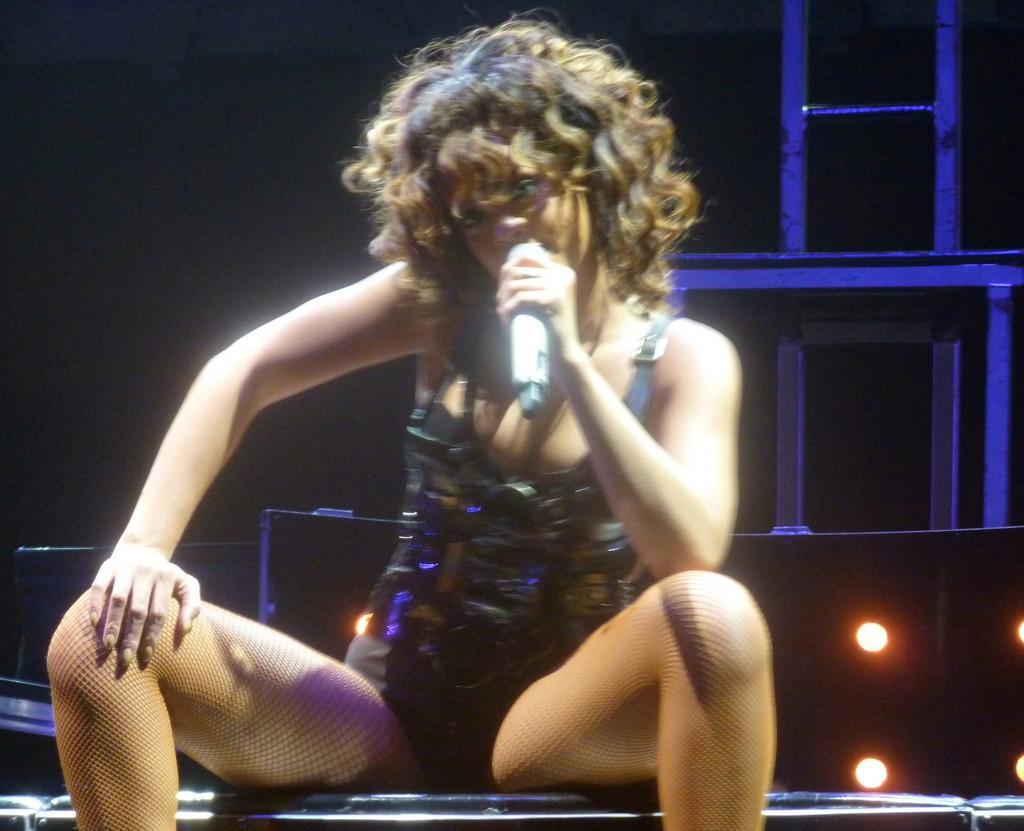Can you describe this image briefly? In this picture I can see a woman sitting in front and I see that she is holding a mic. I can see that it is dark in the background and I can see few few lights on the bottom side of this picture. 